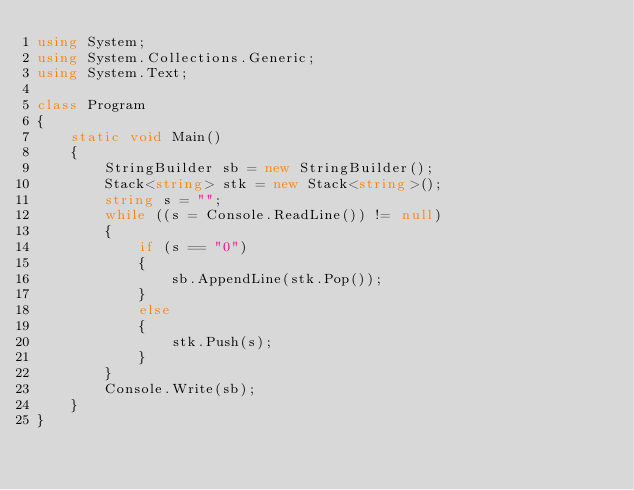<code> <loc_0><loc_0><loc_500><loc_500><_C#_>using System;
using System.Collections.Generic;
using System.Text;

class Program
{
    static void Main()
    {
        StringBuilder sb = new StringBuilder();
        Stack<string> stk = new Stack<string>();
        string s = "";
        while ((s = Console.ReadLine()) != null)
        {
            if (s == "0")
            {
                sb.AppendLine(stk.Pop());
            }
            else
            {
                stk.Push(s);
            }
        }
        Console.Write(sb);
    }
}
</code> 